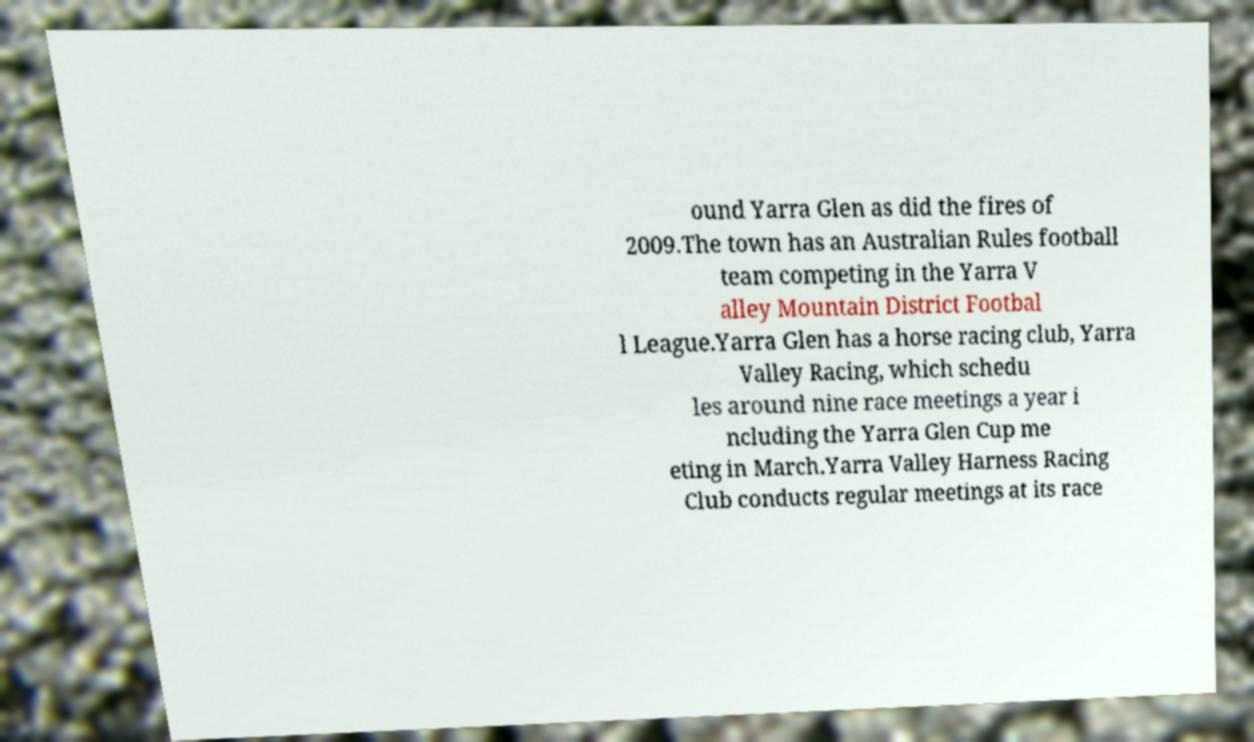Please identify and transcribe the text found in this image. ound Yarra Glen as did the fires of 2009.The town has an Australian Rules football team competing in the Yarra V alley Mountain District Footbal l League.Yarra Glen has a horse racing club, Yarra Valley Racing, which schedu les around nine race meetings a year i ncluding the Yarra Glen Cup me eting in March.Yarra Valley Harness Racing Club conducts regular meetings at its race 